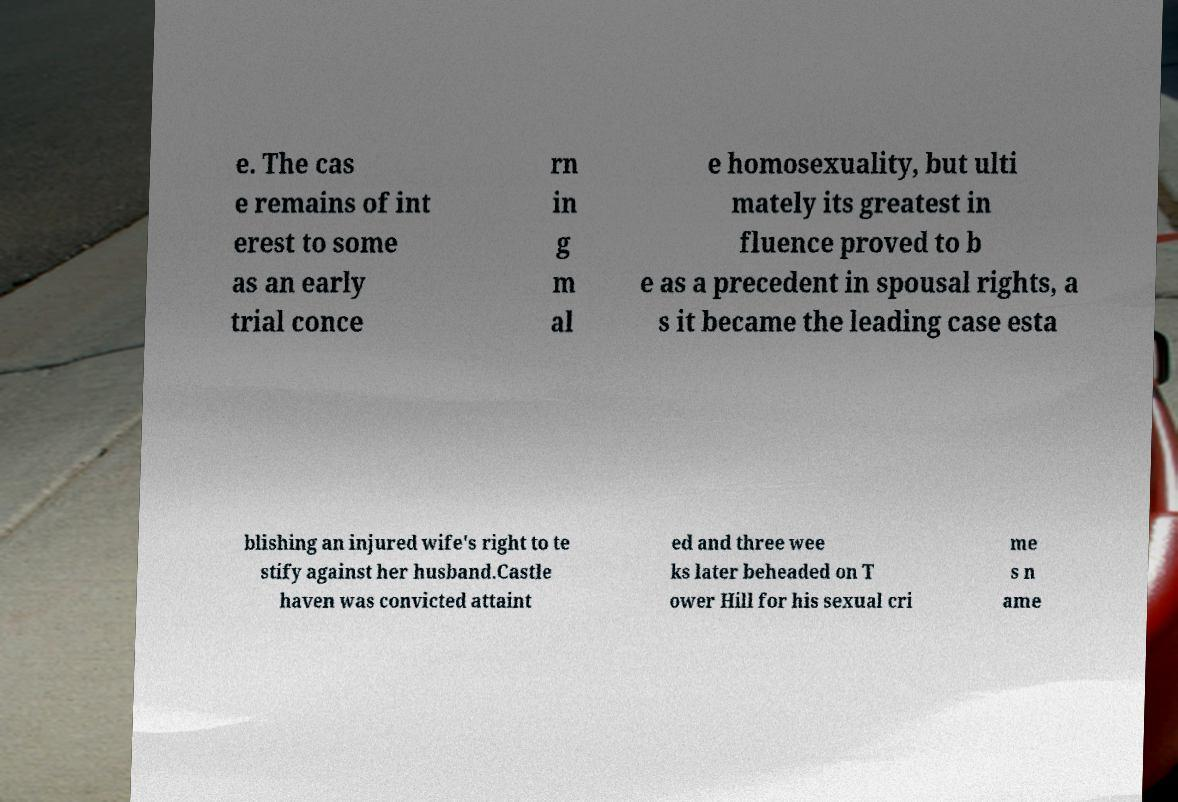There's text embedded in this image that I need extracted. Can you transcribe it verbatim? e. The cas e remains of int erest to some as an early trial conce rn in g m al e homosexuality, but ulti mately its greatest in fluence proved to b e as a precedent in spousal rights, a s it became the leading case esta blishing an injured wife's right to te stify against her husband.Castle haven was convicted attaint ed and three wee ks later beheaded on T ower Hill for his sexual cri me s n ame 